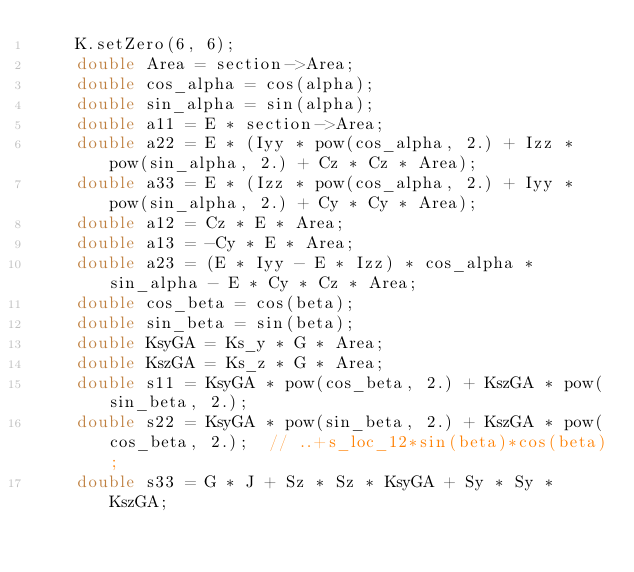<code> <loc_0><loc_0><loc_500><loc_500><_C++_>    K.setZero(6, 6);
    double Area = section->Area;
    double cos_alpha = cos(alpha);
    double sin_alpha = sin(alpha);
    double a11 = E * section->Area;
    double a22 = E * (Iyy * pow(cos_alpha, 2.) + Izz * pow(sin_alpha, 2.) + Cz * Cz * Area);
    double a33 = E * (Izz * pow(cos_alpha, 2.) + Iyy * pow(sin_alpha, 2.) + Cy * Cy * Area);
    double a12 = Cz * E * Area;
    double a13 = -Cy * E * Area;
    double a23 = (E * Iyy - E * Izz) * cos_alpha * sin_alpha - E * Cy * Cz * Area;
    double cos_beta = cos(beta);
    double sin_beta = sin(beta);
    double KsyGA = Ks_y * G * Area;
    double KszGA = Ks_z * G * Area;
    double s11 = KsyGA * pow(cos_beta, 2.) + KszGA * pow(sin_beta, 2.);
    double s22 = KsyGA * pow(sin_beta, 2.) + KszGA * pow(cos_beta, 2.);  // ..+s_loc_12*sin(beta)*cos(beta);
    double s33 = G * J + Sz * Sz * KsyGA + Sy * Sy * KszGA;</code> 